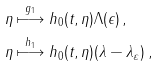<formula> <loc_0><loc_0><loc_500><loc_500>\eta & \stackrel { g _ { 1 } } { \longmapsto } h _ { 0 } ( t , \eta ) \Lambda ( \epsilon ) \, , \\ \eta & \stackrel { h _ { 1 } } { \longmapsto } h _ { 0 } ( t , \eta ) ( \lambda - \lambda _ { \varepsilon } ) \, ,</formula> 